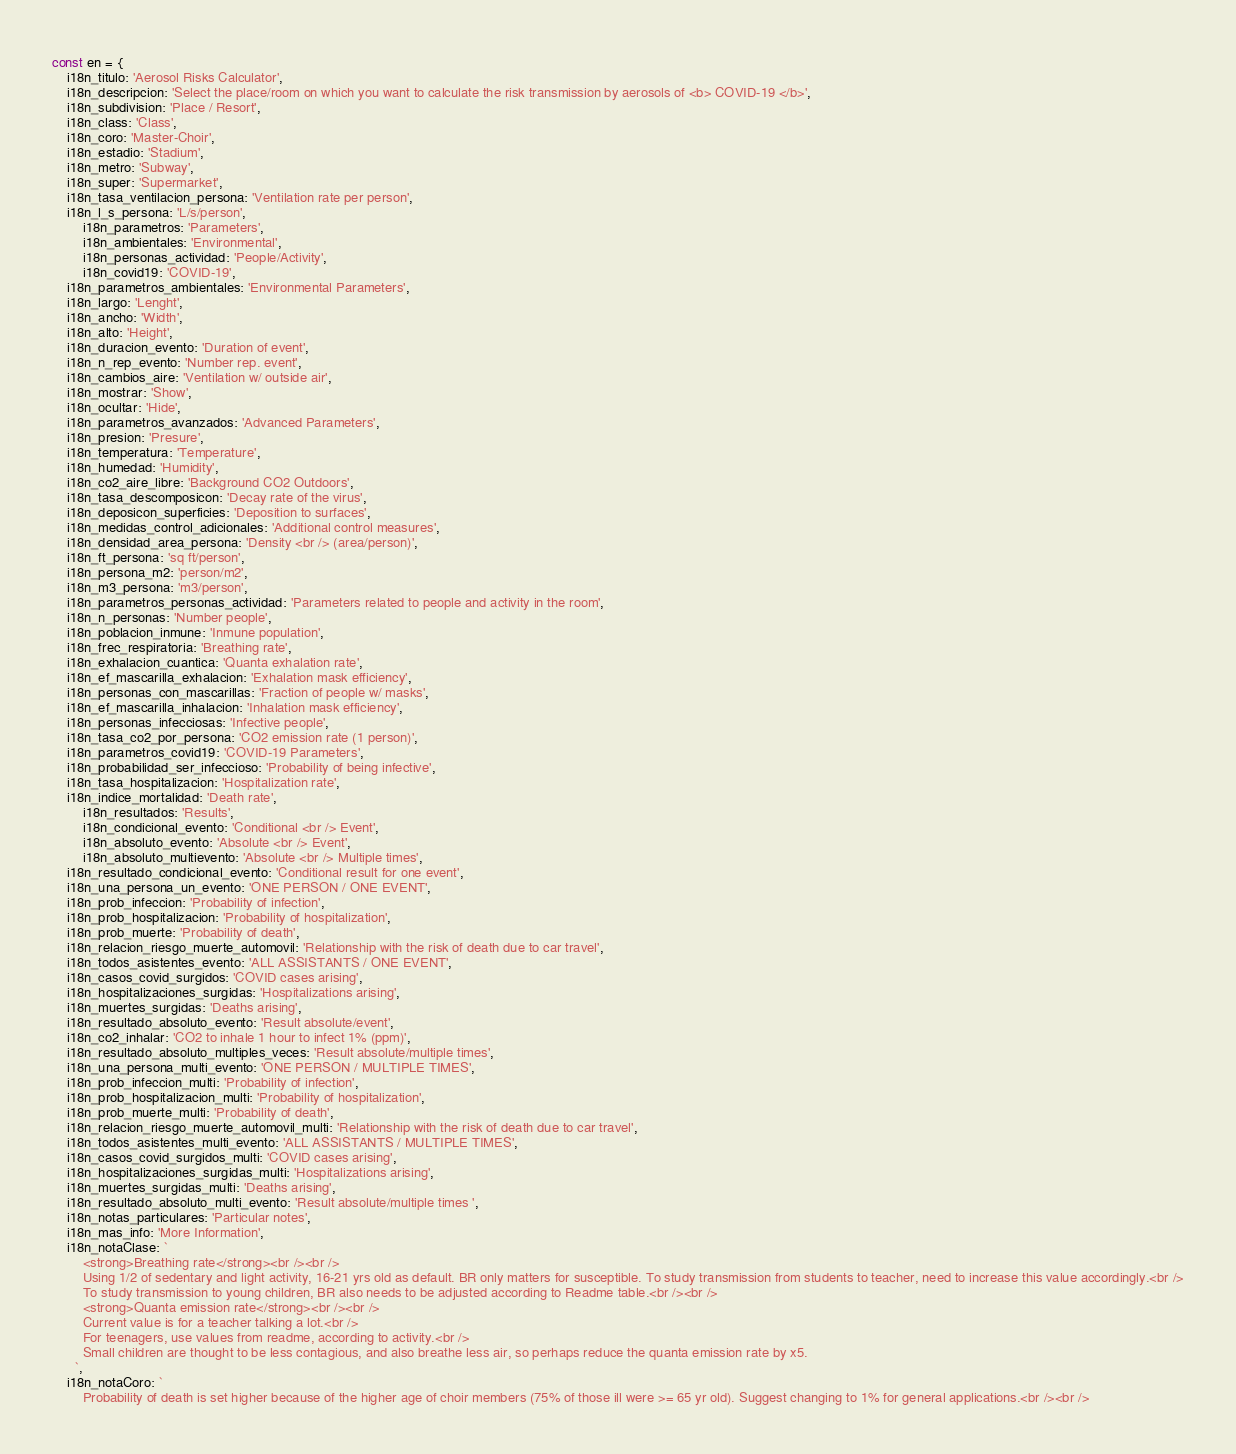Convert code to text. <code><loc_0><loc_0><loc_500><loc_500><_JavaScript_>const en = {
    i18n_titulo: 'Aerosol Risks Calculator',
    i18n_descripcion: 'Select the place/room on which you want to calculate the risk transmission by aerosols of <b> COVID-19 </b>',
    i18n_subdivision: 'Place / Resort',
    i18n_class: 'Class',
    i18n_coro: 'Master-Choir',
    i18n_estadio: 'Stadium',
    i18n_metro: 'Subway',
    i18n_super: 'Supermarket',
    i18n_tasa_ventilacion_persona: 'Ventilation rate per person',
    i18n_l_s_persona: 'L/s/person',
        i18n_parametros: 'Parameters',
        i18n_ambientales: 'Environmental',
        i18n_personas_actividad: 'People/Activity',
        i18n_covid19: 'COVID-19',
    i18n_parametros_ambientales: 'Environmental Parameters',
    i18n_largo: 'Lenght',
    i18n_ancho: 'Width',
    i18n_alto: 'Height',
    i18n_duracion_evento: 'Duration of event',
    i18n_n_rep_evento: 'Number rep. event',
    i18n_cambios_aire: 'Ventilation w/ outside air',
    i18n_mostrar: 'Show',
    i18n_ocultar: 'Hide',
    i18n_parametros_avanzados: 'Advanced Parameters',
    i18n_presion: 'Presure',
    i18n_temperatura: 'Temperature',
    i18n_humedad: 'Humidity',
    i18n_co2_aire_libre: 'Background CO2 Outdoors',
    i18n_tasa_descomposicon: 'Decay rate of the virus',
    i18n_deposicon_superficies: 'Deposition to surfaces',
    i18n_medidas_control_adicionales: 'Additional control measures',
    i18n_densidad_area_persona: 'Density <br /> (area/person)',
    i18n_ft_persona: 'sq ft/person',
    i18n_persona_m2: 'person/m2',
    i18n_m3_persona: 'm3/person',
    i18n_parametros_personas_actividad: 'Parameters related to people and activity in the room',
    i18n_n_personas: 'Number people',
    i18n_poblacion_inmune: 'Inmune population',
    i18n_frec_respiratoria: 'Breathing rate',
    i18n_exhalacion_cuantica: 'Quanta exhalation rate',
    i18n_ef_mascarilla_exhalacion: 'Exhalation mask efficiency',
    i18n_personas_con_mascarillas: 'Fraction of people w/ masks',
    i18n_ef_mascarilla_inhalacion: 'Inhalation mask efficiency',
    i18n_personas_infecciosas: 'Infective people',
    i18n_tasa_co2_por_persona: 'CO2 emission rate (1 person)',
    i18n_parametros_covid19: 'COVID-19 Parameters',
    i18n_probabilidad_ser_infeccioso: 'Probability of being infective',
    i18n_tasa_hospitalizacion: 'Hospitalization rate',
    i18n_indice_mortalidad: 'Death rate',
        i18n_resultados: 'Results',
        i18n_condicional_evento: 'Conditional <br /> Event',
        i18n_absoluto_evento: 'Absolute <br /> Event',
        i18n_absoluto_multievento: 'Absolute <br /> Multiple times',
    i18n_resultado_condicional_evento: 'Conditional result for one event',
    i18n_una_persona_un_evento: 'ONE PERSON / ONE EVENT',
    i18n_prob_infeccion: 'Probability of infection',
    i18n_prob_hospitalizacion: 'Probability of hospitalization',
    i18n_prob_muerte: 'Probability of death',
    i18n_relacion_riesgo_muerte_automovil: 'Relationship with the risk of death due to car travel',
    i18n_todos_asistentes_evento: 'ALL ASSISTANTS / ONE EVENT',
    i18n_casos_covid_surgidos: 'COVID cases arising',
    i18n_hospitalizaciones_surgidas: 'Hospitalizations arising',
    i18n_muertes_surgidas: 'Deaths arising',
    i18n_resultado_absoluto_evento: 'Result absolute/event',
    i18n_co2_inhalar: 'CO2 to inhale 1 hour to infect 1% (ppm)',
    i18n_resultado_absoluto_multiples_veces: 'Result absolute/multiple times',
    i18n_una_persona_multi_evento: 'ONE PERSON / MULTIPLE TIMES',
    i18n_prob_infeccion_multi: 'Probability of infection',
    i18n_prob_hospitalizacion_multi: 'Probability of hospitalization',
    i18n_prob_muerte_multi: 'Probability of death',
    i18n_relacion_riesgo_muerte_automovil_multi: 'Relationship with the risk of death due to car travel',
    i18n_todos_asistentes_multi_evento: 'ALL ASSISTANTS / MULTIPLE TIMES',
    i18n_casos_covid_surgidos_multi: 'COVID cases arising',
    i18n_hospitalizaciones_surgidas_multi: 'Hospitalizations arising',
    i18n_muertes_surgidas_multi: 'Deaths arising',
    i18n_resultado_absoluto_multi_evento: 'Result absolute/multiple times ',
    i18n_notas_particulares: 'Particular notes',
    i18n_mas_info: 'More Information',
    i18n_notaClase: `
        <strong>Breathing rate</strong><br /><br />
        Using 1/2 of sedentary and light activity, 16-21 yrs old as default. BR only matters for susceptible. To study transmission from students to teacher, need to increase this value accordingly.<br />
        To study transmission to young children, BR also needs to be adjusted according to Readme table.<br /><br />
        <strong>Quanta emission rate</strong><br /><br />
        Current value is for a teacher talking a lot.<br />
        For teenagers, use values from readme, according to activity.<br />
        Small children are thought to be less contagious, and also breathe less air, so perhaps reduce the quanta emission rate by x5.
      `,
    i18n_notaCoro: `
        Probability of death is set higher because of the higher age of choir members (75% of those ill were >= 65 yr old). Suggest changing to 1% for general applications.<br /><br /></code> 